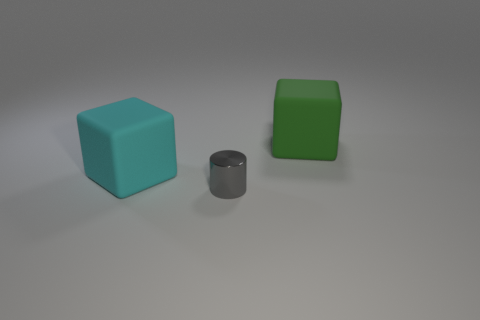What is the material of the other cube that is the same size as the cyan cube?
Make the answer very short. Rubber. How many big objects are either red metallic cubes or blocks?
Your answer should be compact. 2. Is the shape of the small gray shiny thing the same as the cyan object?
Your response must be concise. No. How many objects are both in front of the cyan matte thing and behind the cylinder?
Your answer should be compact. 0. Is there anything else of the same color as the metal object?
Your response must be concise. No. There is another big thing that is made of the same material as the green thing; what is its shape?
Ensure brevity in your answer.  Cube. Do the cyan rubber cube and the gray metallic thing have the same size?
Keep it short and to the point. No. Is the big green thing that is behind the tiny gray thing made of the same material as the tiny gray cylinder?
Provide a succinct answer. No. Are there any other things that are made of the same material as the gray cylinder?
Provide a short and direct response. No. How many big objects are behind the rubber object right of the block that is in front of the green object?
Your response must be concise. 0. 